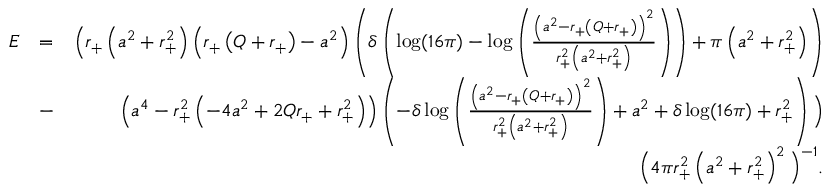Convert formula to latex. <formula><loc_0><loc_0><loc_500><loc_500>\begin{array} { r l r } { E } & { = } & { \left ( r _ { + } \left ( a ^ { 2 } + r _ { + } ^ { 2 } \right ) \left ( r _ { + } \left ( Q + r _ { + } \right ) - a ^ { 2 } \right ) \left ( \delta \left ( \log ( 1 6 \pi ) - \log \left ( \frac { \left ( a ^ { 2 } - r _ { + } \left ( Q + r _ { + } \right ) \right ) ^ { 2 } } { r _ { + } ^ { 2 } \left ( a ^ { 2 } + r _ { + } ^ { 2 } \right ) } \right ) \right ) + \pi \left ( a ^ { 2 } + r _ { + } ^ { 2 } \right ) \right ) } \\ & { - } & { \left ( a ^ { 4 } - r _ { + } ^ { 2 } \left ( - 4 a ^ { 2 } + 2 Q r _ { + } + r _ { + } ^ { 2 } \right ) \right ) \left ( - \delta \log \left ( \frac { \left ( a ^ { 2 } - r _ { + } \left ( Q + r _ { + } \right ) \right ) ^ { 2 } } { r _ { + } ^ { 2 } \left ( a ^ { 2 } + r _ { + } ^ { 2 } \right ) } \right ) + a ^ { 2 } + \delta \log ( 1 6 \pi ) + r _ { + } ^ { 2 } \right ) \right ) } \\ & { \left ( 4 \pi r _ { + } ^ { 2 } \left ( a ^ { 2 } + r _ { + } ^ { 2 } \right ) ^ { 2 } \right ) ^ { - 1 } . } \end{array}</formula> 